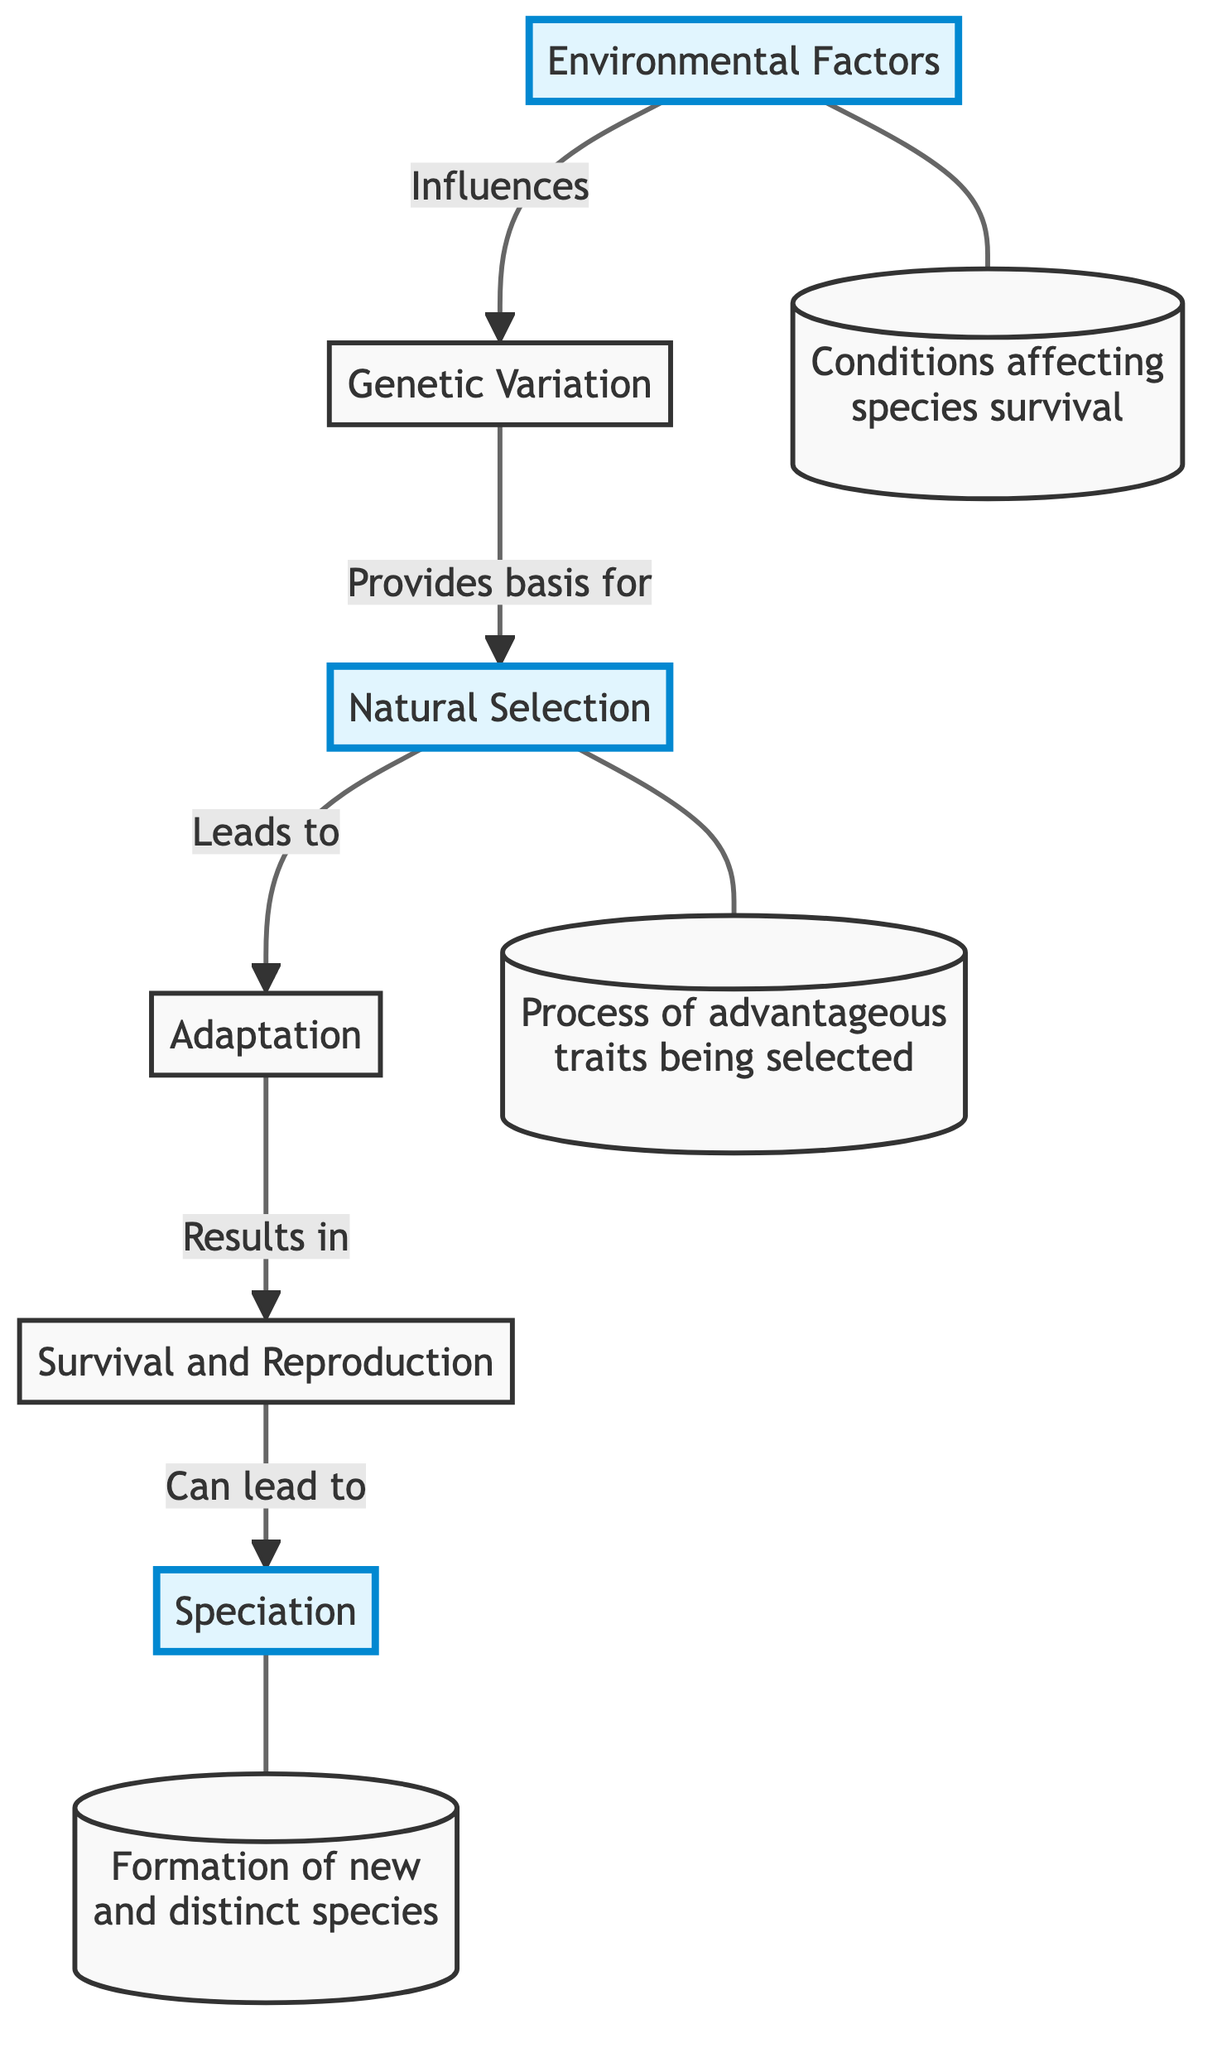What is the first element in the flowchart? The first element is "Environmental Factors", as it is the starting point of the flow leading to the other elements.
Answer: Environmental Factors How many elements are there in the flowchart? There are six elements in the flowchart, each represented by a distinct node that conveys information about animal adaptation processes.
Answer: 6 What does "Genetic Variation" provide the basis for? "Genetic Variation" provides the basis for "Natural Selection", showing the connection between these two processes in animal adaptation.
Answer: Natural Selection What leads from "Natural Selection" to "Adaptation"? The flowchart indicates that "Natural Selection" directly leads to "Adaptation", meaning that the advantageous traits selected through natural selection result in changes in species over generations.
Answer: Adaptation What can result from "Survival and Reproduction"? "Survival and Reproduction" can lead to "Speciation", indicating that successful reproduction can create new species over evolutionary time.
Answer: Speciation Which element is influenced by "Environmental Factors"? "Genetic Variation" is influenced by "Environmental Factors", suggesting that the conditions impacting survival can affect genetic diversity within a species.
Answer: Genetic Variation What do successful individuals pass on to the next generation? Successful individuals pass on their traits to the next generation, which is a key aspect of how evolution works through the process described in the flowchart.
Answer: Traits Which two elements are highlighted in the flowchart? The highlighted elements are "Environmental Factors", "Natural Selection", and "Speciation". This highlighting denotes their significance within the adaptation processes shown.
Answer: Environmental Factors, Natural Selection, Speciation What is the relationship between "Adaptation" and "Survival and Reproduction"? "Adaptation" results in "Survival and Reproduction", illustrating how successful adaptations enable species to thrive and reproduce in their environments.
Answer: Survival and Reproduction 